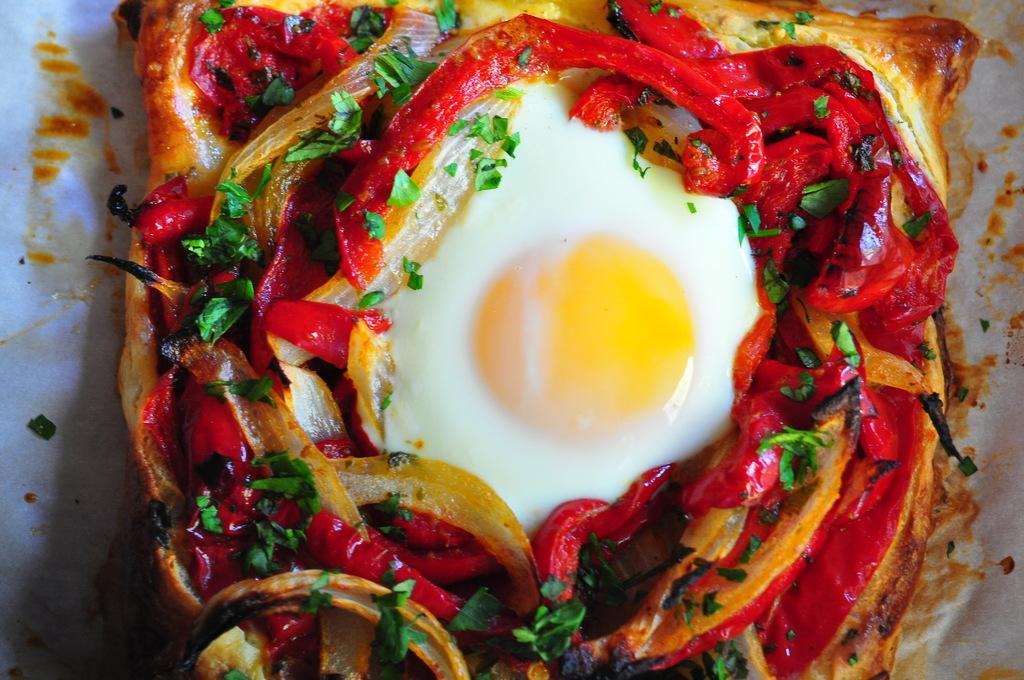In one or two sentences, can you explain what this image depicts? In this picture I can see there is some food and it is placed on a thin paper and the food has onions, egg white and yolk and coriander. 